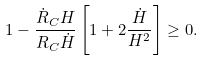<formula> <loc_0><loc_0><loc_500><loc_500>1 - \frac { \dot { R } _ { C } H } { R _ { C } \dot { H } } \left [ 1 + 2 \frac { \dot { H } } { H ^ { 2 } } \right ] \geq 0 .</formula> 